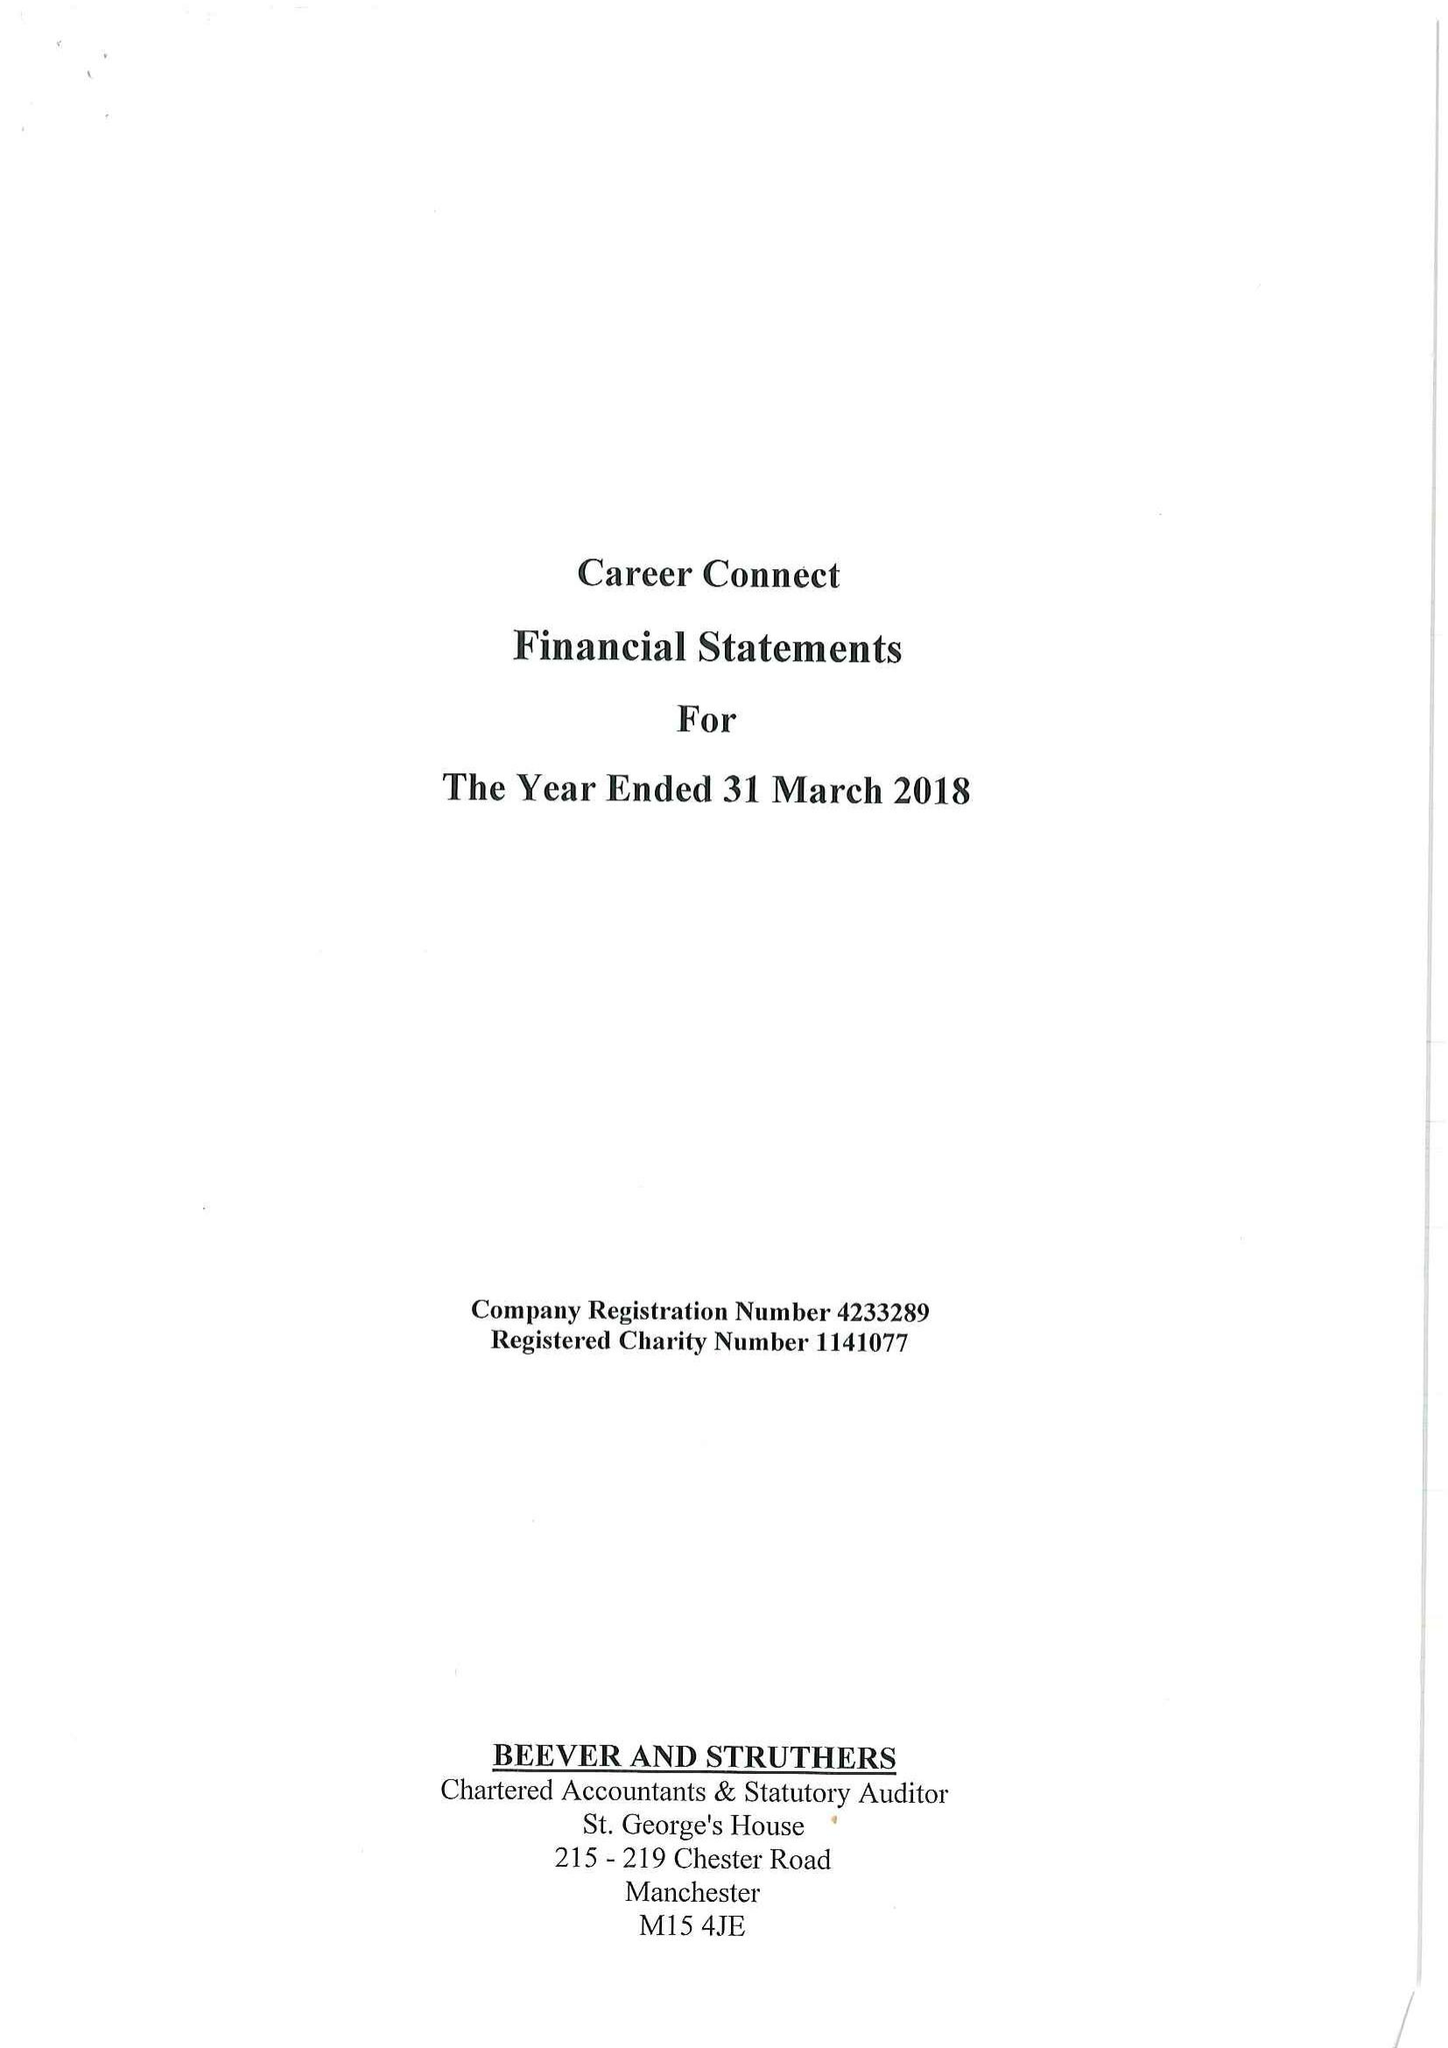What is the value for the address__post_town?
Answer the question using a single word or phrase. LIVERPOOL 